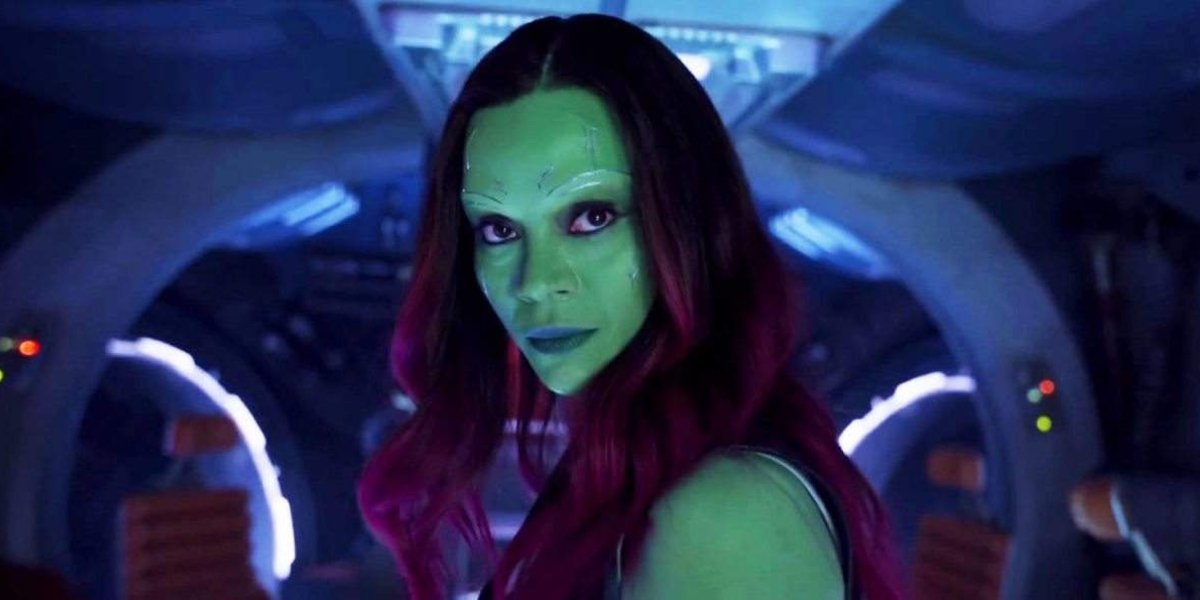Can you describe the main features of this image for me?
 In this image, we see the actress Zoe Saldana, transformed into her character Gamora from the movie Guardians of the Galaxy. She stands in the interior of a spaceship, her face painted an intense shade of green, contrasting with her vibrant red hair. Her gaze is directed straight at the camera, a serious expression etched on her face. The spaceship around her is bathed in a mix of blue and orange lights, creating an atmosphere that speaks to the intergalactic setting of her character's adventures. 